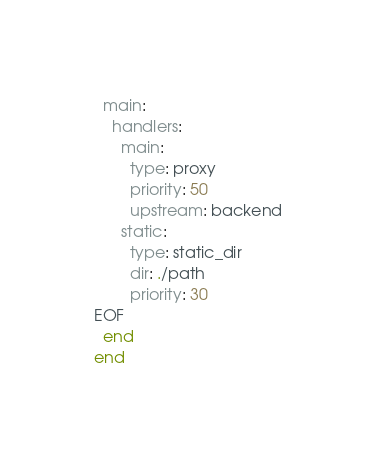Convert code to text. <code><loc_0><loc_0><loc_500><loc_500><_Ruby_>  main:
    handlers:
      main:
        type: proxy
        priority: 50
        upstream: backend
      static:
        type: static_dir
        dir: ./path
        priority: 30
EOF
  end
end
</code> 